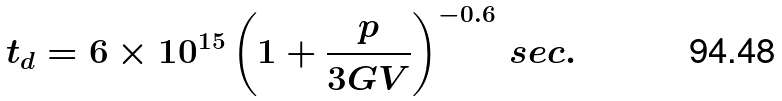<formula> <loc_0><loc_0><loc_500><loc_500>t _ { d } = 6 \times 1 0 ^ { 1 5 } \left ( 1 + \frac { p } { 3 G V } \right ) ^ { - 0 . 6 } \, s e c .</formula> 